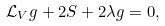Convert formula to latex. <formula><loc_0><loc_0><loc_500><loc_500>\mathcal { L } _ { V } g + 2 S + 2 \lambda g = 0 ,</formula> 